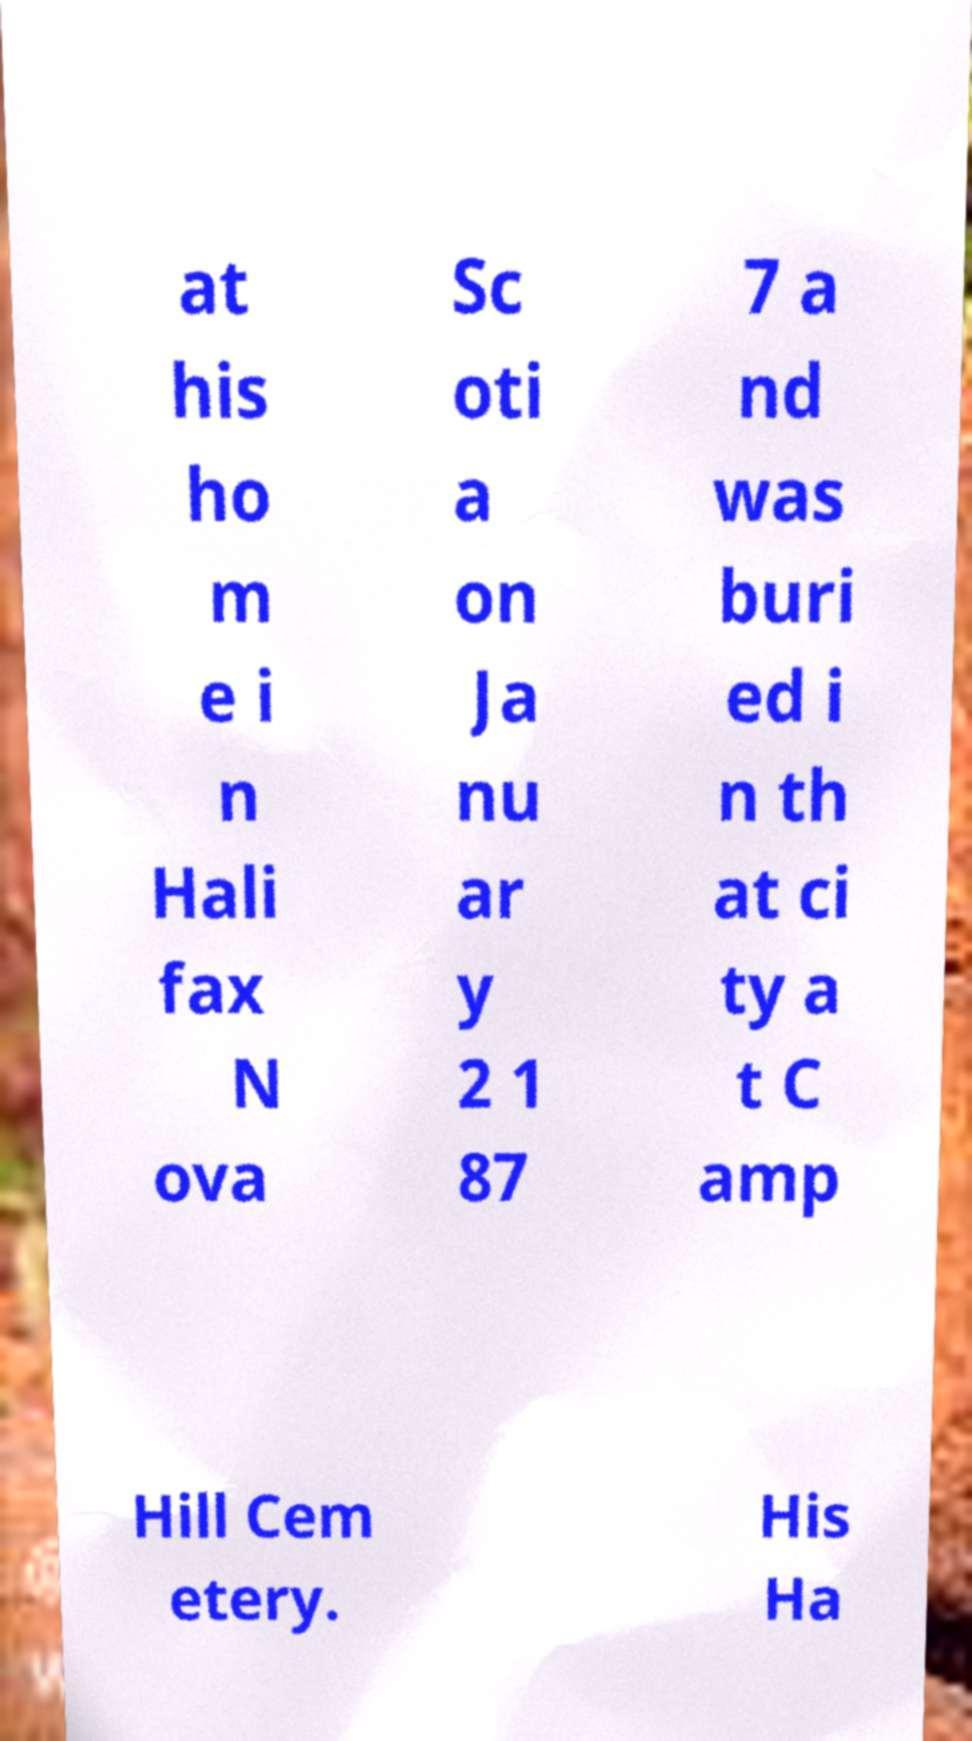Can you accurately transcribe the text from the provided image for me? at his ho m e i n Hali fax N ova Sc oti a on Ja nu ar y 2 1 87 7 a nd was buri ed i n th at ci ty a t C amp Hill Cem etery. His Ha 